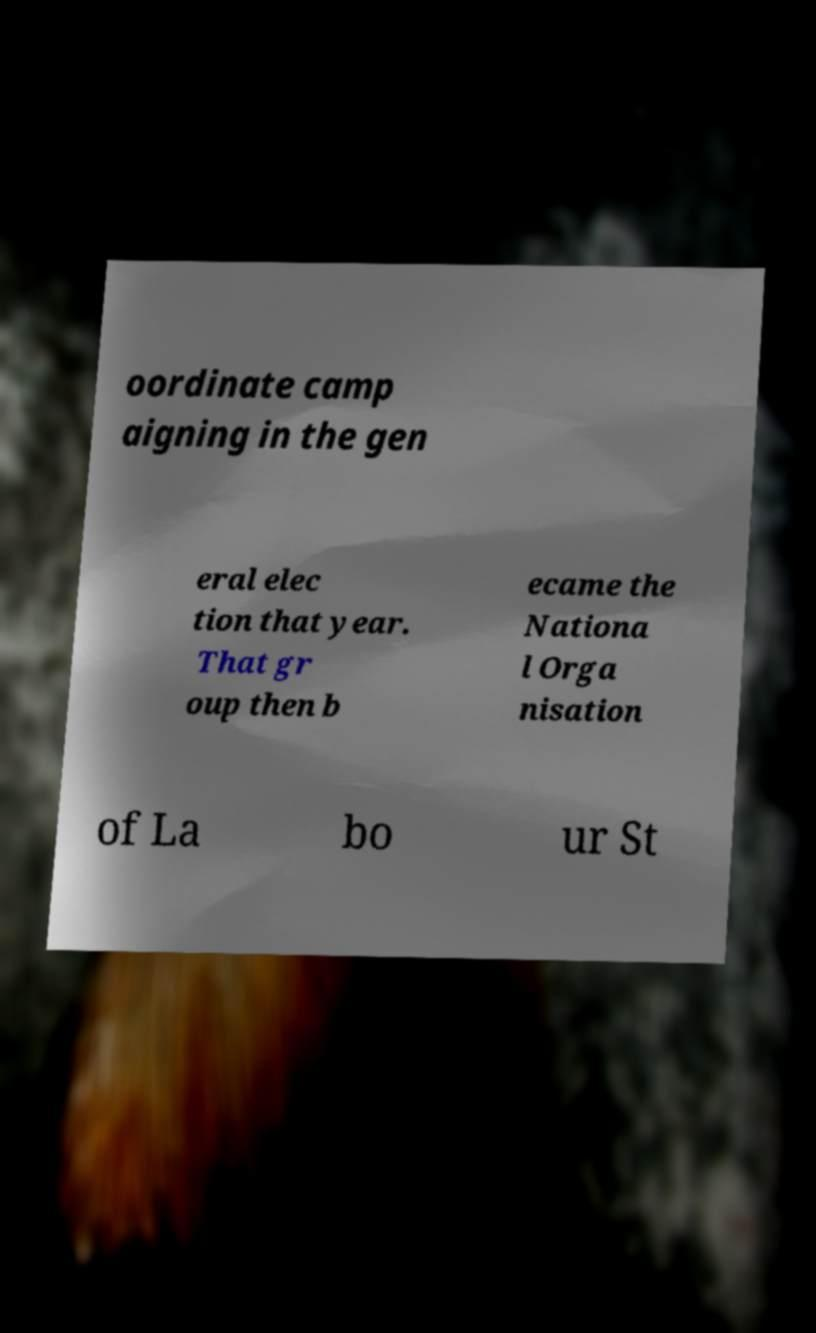Please identify and transcribe the text found in this image. oordinate camp aigning in the gen eral elec tion that year. That gr oup then b ecame the Nationa l Orga nisation of La bo ur St 